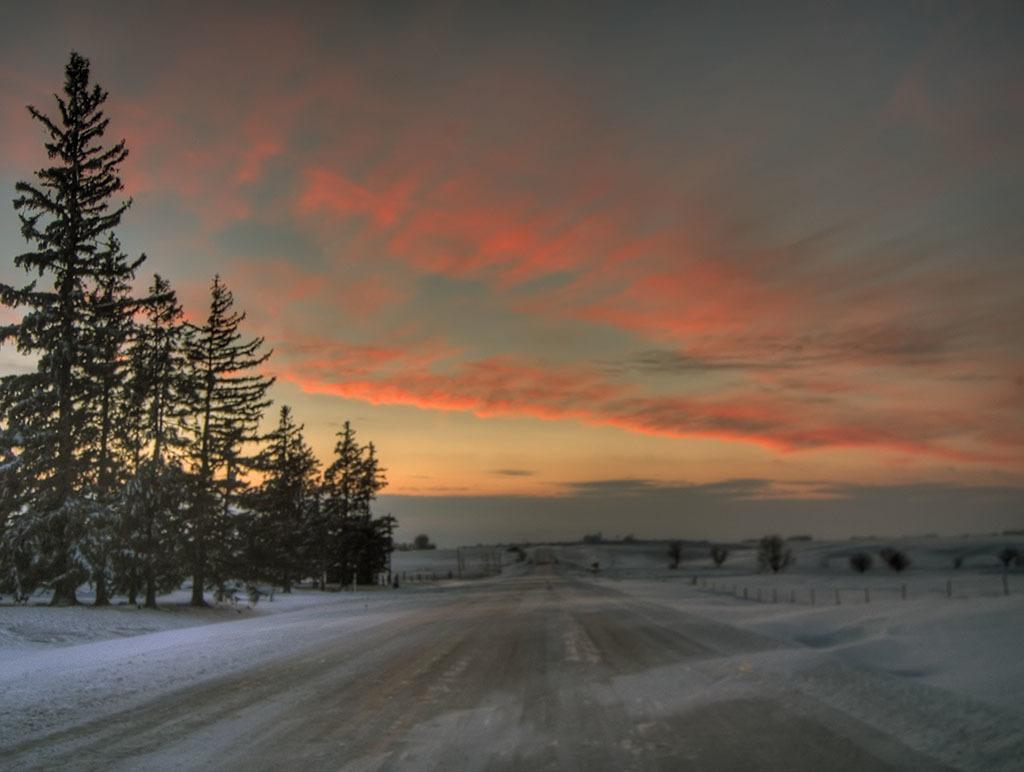How would you summarize this image in a sentence or two? This image consists of a road. To the left and right, there is snow. To the left, there are trees. At the top, the sky is in red color. 